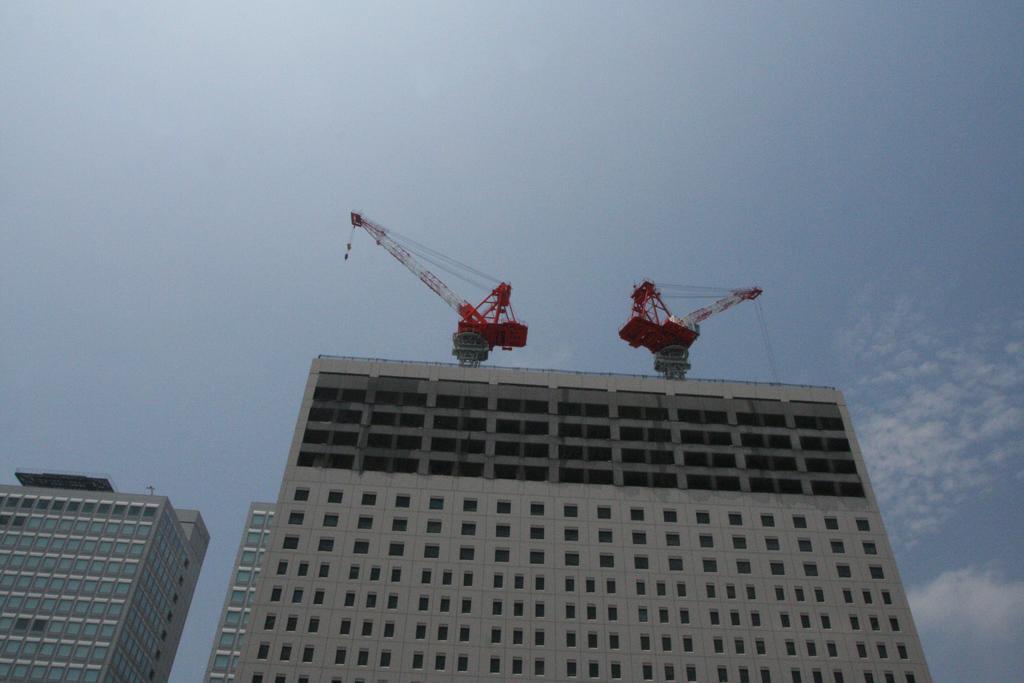Please provide a concise description of this image. In this image we can see some buildings with windows. We can also see two cranes on a building and the sky which looks cloudy. 